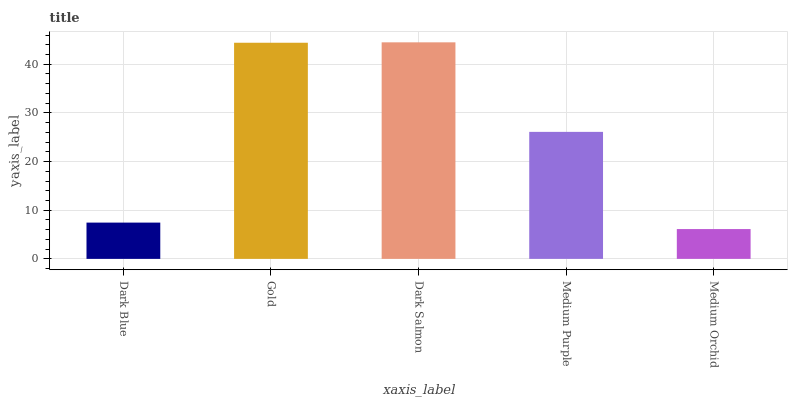Is Medium Orchid the minimum?
Answer yes or no. Yes. Is Dark Salmon the maximum?
Answer yes or no. Yes. Is Gold the minimum?
Answer yes or no. No. Is Gold the maximum?
Answer yes or no. No. Is Gold greater than Dark Blue?
Answer yes or no. Yes. Is Dark Blue less than Gold?
Answer yes or no. Yes. Is Dark Blue greater than Gold?
Answer yes or no. No. Is Gold less than Dark Blue?
Answer yes or no. No. Is Medium Purple the high median?
Answer yes or no. Yes. Is Medium Purple the low median?
Answer yes or no. Yes. Is Dark Blue the high median?
Answer yes or no. No. Is Dark Blue the low median?
Answer yes or no. No. 